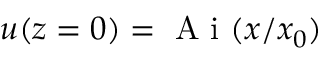Convert formula to latex. <formula><loc_0><loc_0><loc_500><loc_500>u ( z = 0 ) = A i ( x / x _ { 0 } )</formula> 